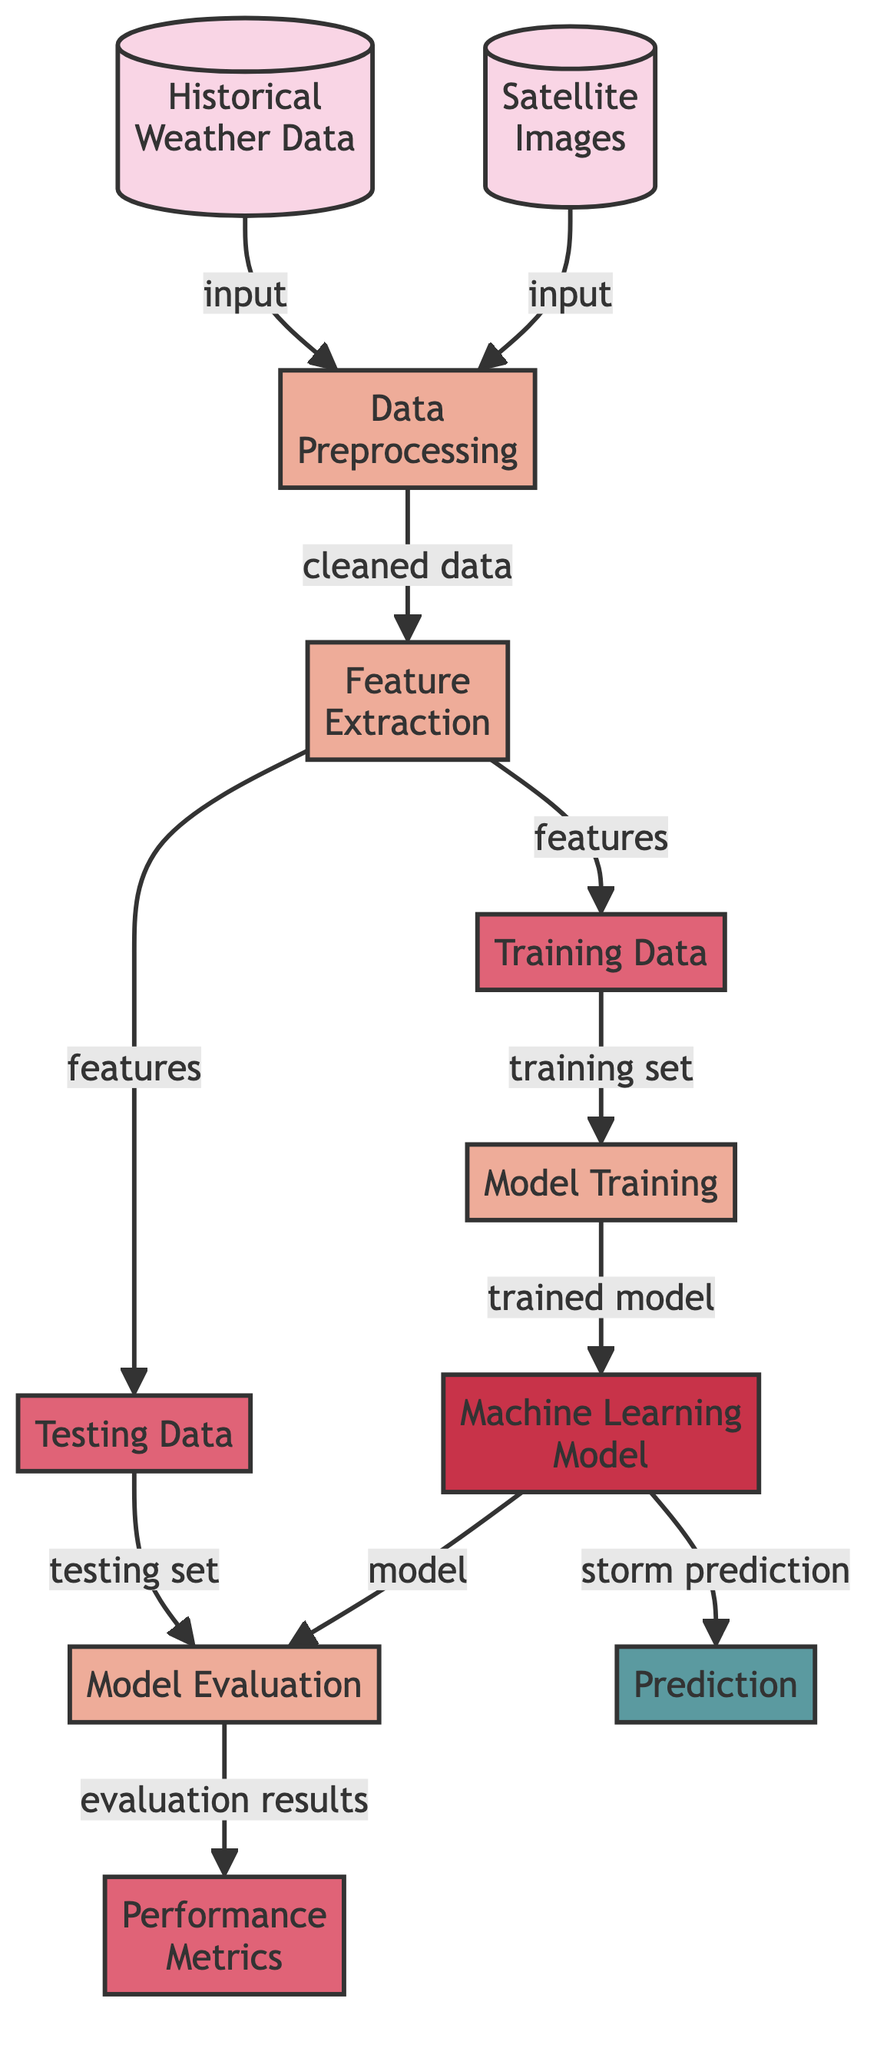What data sources are used in this diagram? The diagram identifies two distinct data sources: "Historical Weather Data" and "Satellite Images." Both of these input the data necessary for the next steps in the processing.
Answer: Historical Weather Data and Satellite Images How many processing steps are there in the diagram? There are four processing steps: "Data Preprocessing," "Feature Extraction," "Model Training," and "Model Evaluation."
Answer: Four What type of data is produced after feature extraction? After feature extraction, the output is categorized into "Training Data" and "Testing Data," which are used in subsequent steps.
Answer: Training Data and Testing Data What does the "Model Training" node lead to? The "Model Training" node leads to the "Machine Learning Model," documenting the transition from training to the model's establishment.
Answer: Machine Learning Model How many data outputs are indicated in the diagram? The diagram indicates three data outputs: "Training Data," "Testing Data," and "Performance Metrics."
Answer: Three What is the final outcome of the diagram? The final outcome of the diagram is "Prediction," which is the end goal of the machine learning process depicted.
Answer: Prediction What type of analysis is conducted on the model? The analysis conducted on the model is termed "Model Evaluation," where the performance of the machine learning model is examined.
Answer: Model Evaluation Which node receives the training set for further processing? The node that receives the training set for further processing is "Model Training," which is crucial for developing the machine learning model.
Answer: Model Training What does the "Machine Learning Model" generate besides predicting storms? The "Machine Learning Model" also generates "evaluation results," which provides insights into the model's effectiveness.
Answer: Evaluation Results 